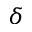<formula> <loc_0><loc_0><loc_500><loc_500>\delta</formula> 